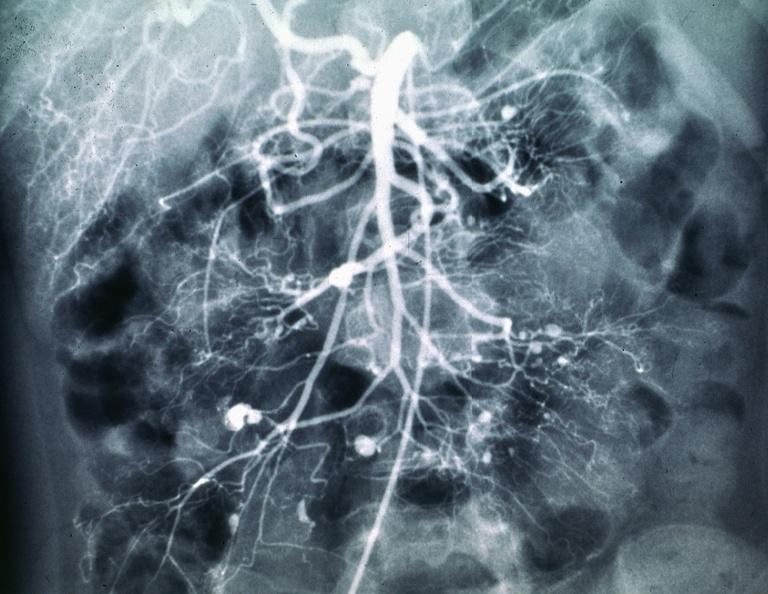s tuberculous peritonitis present?
Answer the question using a single word or phrase. No 